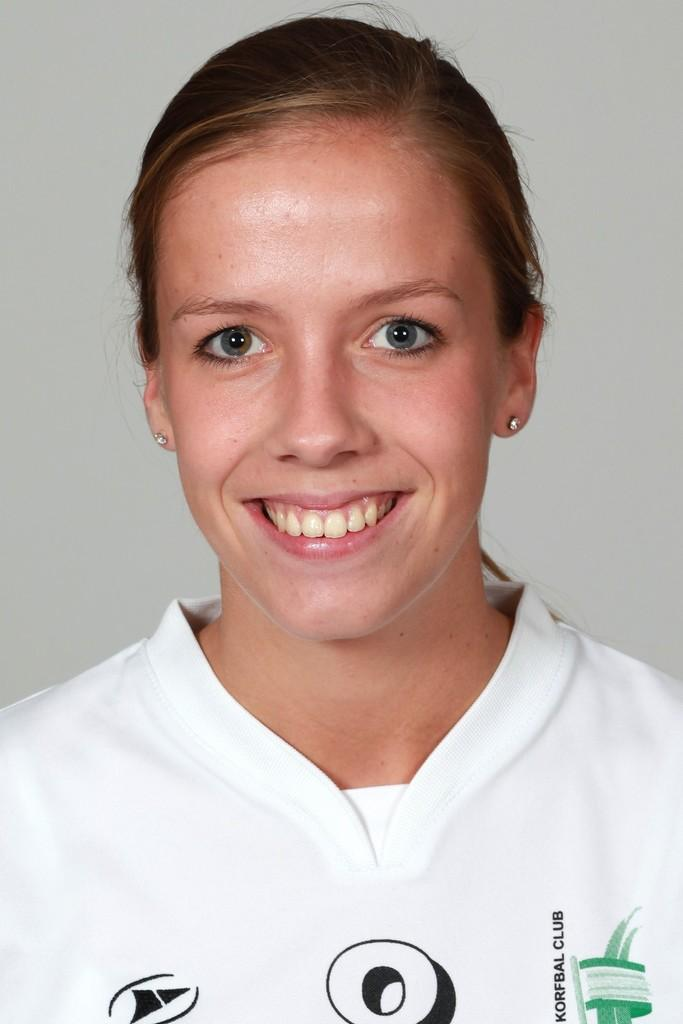Who or what is the main subject of the image? There is a person in the image. What can be observed about the person's attire? The person is wearing clothes. What color or tone is the background of the image? The background of the image is gray. What type of watch is the person wearing in the image? There is no watch visible in the image. What kind of dress is the person wearing in the image? The person's clothing is not described in enough detail to determine the type of dress they are wearing. 